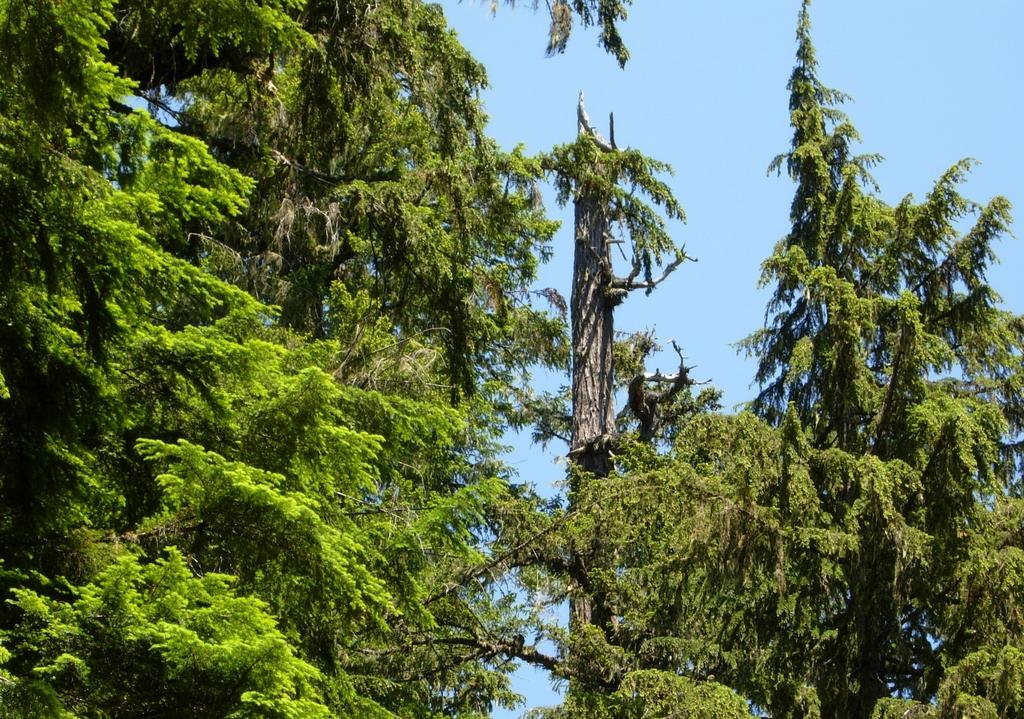What type of vegetation is visible in the image? There are many trees in the image. What color is the sky in the image? The sky is blue in the image. Where is the comb located in the image? There is no comb present in the image. What type of faucet can be seen in the image? There is no faucet present in the image. 